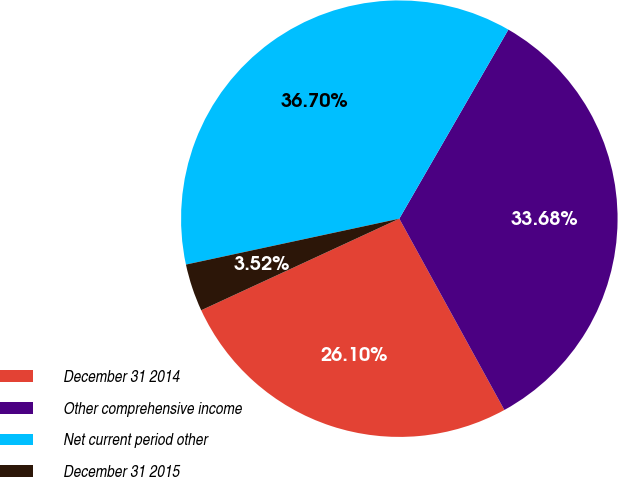Convert chart. <chart><loc_0><loc_0><loc_500><loc_500><pie_chart><fcel>December 31 2014<fcel>Other comprehensive income<fcel>Net current period other<fcel>December 31 2015<nl><fcel>26.1%<fcel>33.68%<fcel>36.7%<fcel>3.52%<nl></chart> 